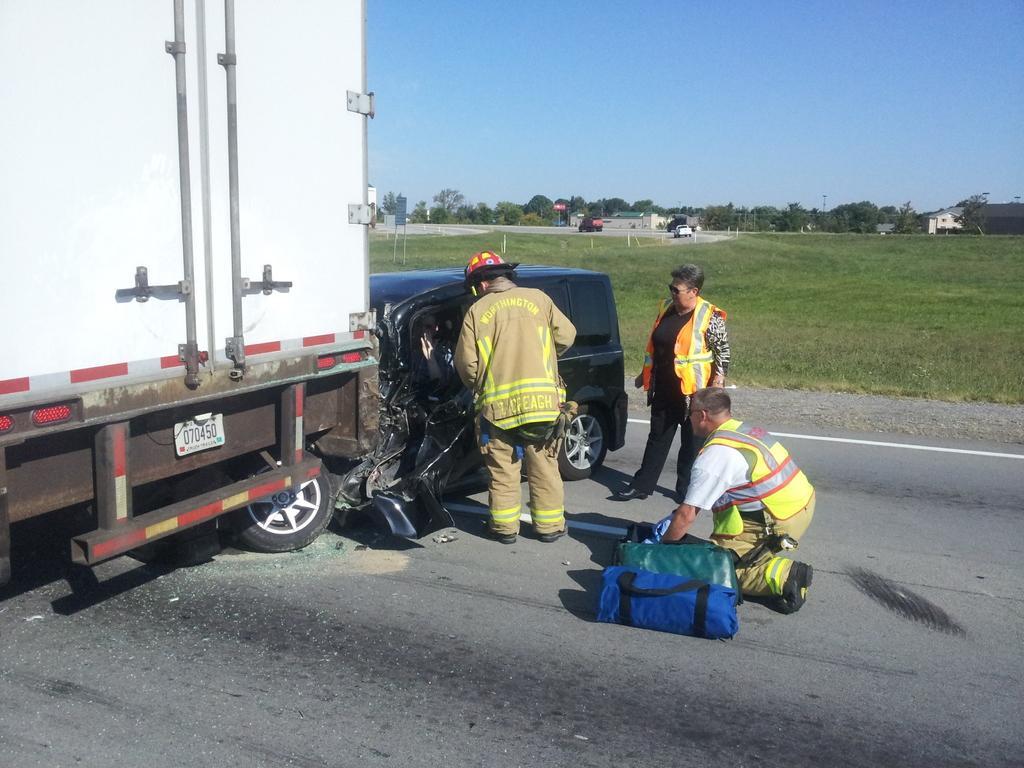In one or two sentences, can you explain what this image depicts? In this picture, we can see a few vehicles and a damaged vehicle and we can see the ground covered with grass, trees, buildings, poles, and the sky. 